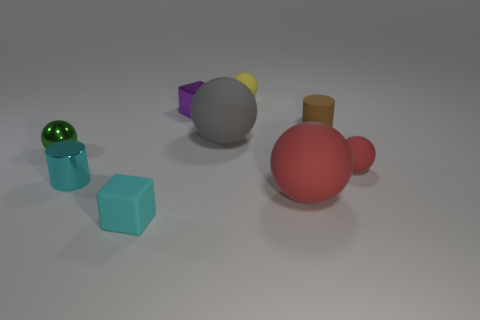Add 1 cyan shiny objects. How many objects exist? 10 Subtract all big gray spheres. How many spheres are left? 4 Subtract all purple cylinders. How many red spheres are left? 2 Subtract all cyan cylinders. How many cylinders are left? 1 Subtract 1 blocks. How many blocks are left? 1 Subtract all gray blocks. Subtract all brown balls. How many blocks are left? 2 Subtract all brown rubber spheres. Subtract all small objects. How many objects are left? 2 Add 6 tiny yellow rubber objects. How many tiny yellow rubber objects are left? 7 Add 1 small cyan cylinders. How many small cyan cylinders exist? 2 Subtract 0 brown balls. How many objects are left? 9 